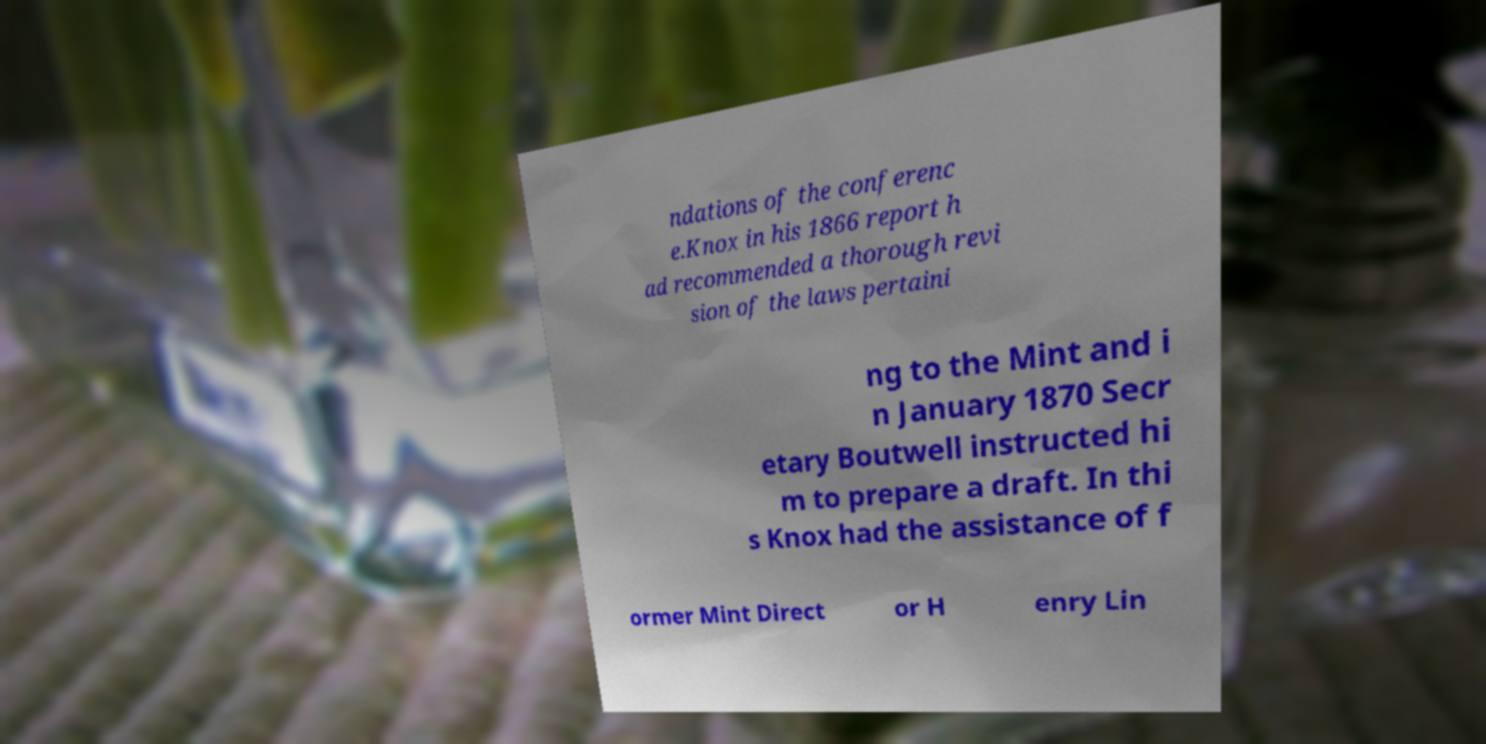Please identify and transcribe the text found in this image. ndations of the conferenc e.Knox in his 1866 report h ad recommended a thorough revi sion of the laws pertaini ng to the Mint and i n January 1870 Secr etary Boutwell instructed hi m to prepare a draft. In thi s Knox had the assistance of f ormer Mint Direct or H enry Lin 